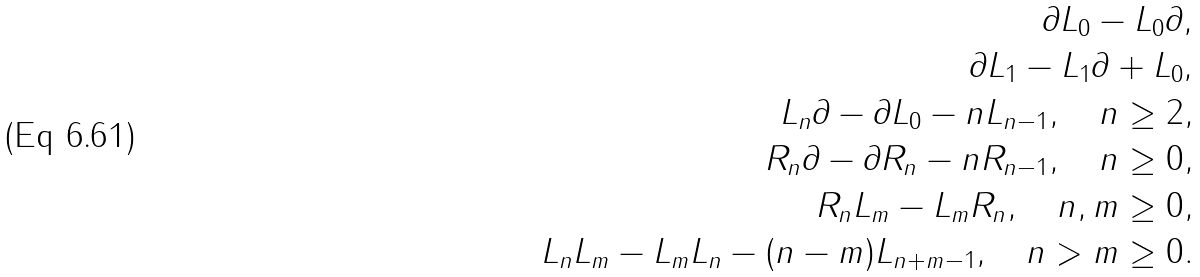<formula> <loc_0><loc_0><loc_500><loc_500>\partial L _ { 0 } - L _ { 0 } \partial , \\ \partial L _ { 1 } - L _ { 1 } \partial + L _ { 0 } , \\ L _ { n } \partial - \partial L _ { 0 } - n L _ { n - 1 } , \quad n \geq 2 , \\ R _ { n } \partial - \partial R _ { n } - n R _ { n - 1 } , \quad n \geq 0 , \\ R _ { n } L _ { m } - L _ { m } R _ { n } , \quad n , m \geq 0 , \\ L _ { n } L _ { m } - L _ { m } L _ { n } - ( n - m ) L _ { n + m - 1 } , \quad n > m \geq 0 .</formula> 